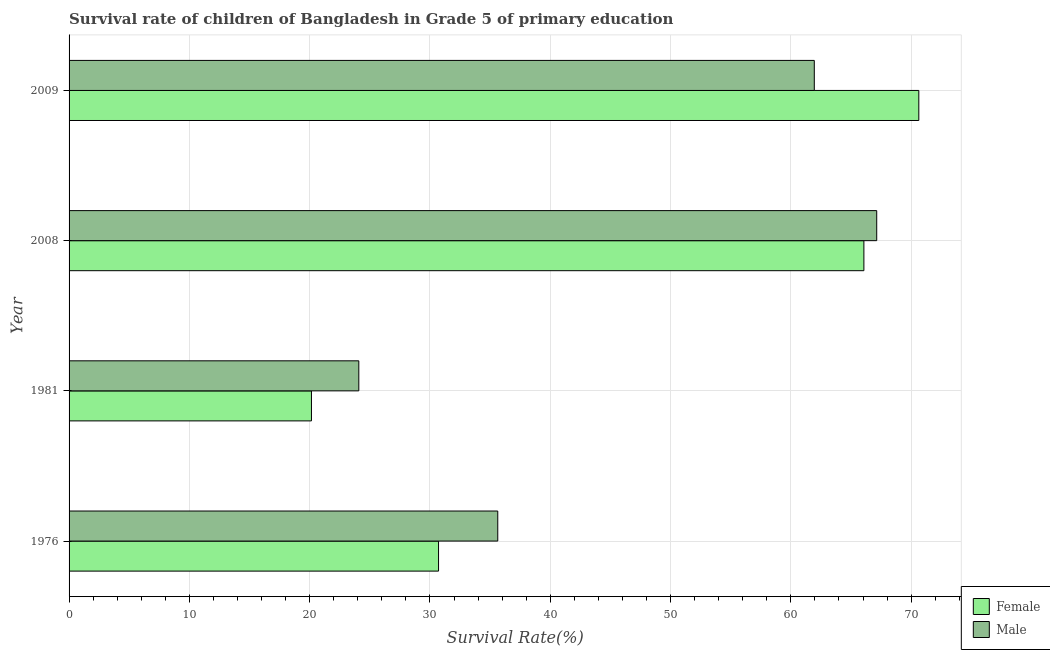How many groups of bars are there?
Give a very brief answer. 4. Are the number of bars on each tick of the Y-axis equal?
Offer a very short reply. Yes. How many bars are there on the 2nd tick from the top?
Your answer should be compact. 2. What is the label of the 1st group of bars from the top?
Your answer should be very brief. 2009. What is the survival rate of male students in primary education in 1976?
Provide a succinct answer. 35.64. Across all years, what is the maximum survival rate of female students in primary education?
Provide a succinct answer. 70.64. Across all years, what is the minimum survival rate of female students in primary education?
Provide a succinct answer. 20.15. What is the total survival rate of male students in primary education in the graph?
Ensure brevity in your answer.  188.81. What is the difference between the survival rate of female students in primary education in 2008 and that in 2009?
Give a very brief answer. -4.57. What is the difference between the survival rate of male students in primary education in 1976 and the survival rate of female students in primary education in 2008?
Your answer should be very brief. -30.43. What is the average survival rate of female students in primary education per year?
Make the answer very short. 46.89. In the year 1981, what is the difference between the survival rate of female students in primary education and survival rate of male students in primary education?
Make the answer very short. -3.94. What is the ratio of the survival rate of female students in primary education in 1976 to that in 2009?
Provide a short and direct response. 0.43. Is the survival rate of male students in primary education in 2008 less than that in 2009?
Your answer should be very brief. No. Is the difference between the survival rate of female students in primary education in 2008 and 2009 greater than the difference between the survival rate of male students in primary education in 2008 and 2009?
Make the answer very short. No. What is the difference between the highest and the second highest survival rate of male students in primary education?
Offer a very short reply. 5.19. What is the difference between the highest and the lowest survival rate of female students in primary education?
Keep it short and to the point. 50.49. In how many years, is the survival rate of male students in primary education greater than the average survival rate of male students in primary education taken over all years?
Your response must be concise. 2. What does the 2nd bar from the top in 2009 represents?
Make the answer very short. Female. How many bars are there?
Offer a terse response. 8. Are the values on the major ticks of X-axis written in scientific E-notation?
Your answer should be very brief. No. Where does the legend appear in the graph?
Offer a very short reply. Bottom right. How many legend labels are there?
Give a very brief answer. 2. How are the legend labels stacked?
Provide a short and direct response. Vertical. What is the title of the graph?
Provide a short and direct response. Survival rate of children of Bangladesh in Grade 5 of primary education. Does "Male labourers" appear as one of the legend labels in the graph?
Offer a very short reply. No. What is the label or title of the X-axis?
Offer a very short reply. Survival Rate(%). What is the label or title of the Y-axis?
Give a very brief answer. Year. What is the Survival Rate(%) of Female in 1976?
Keep it short and to the point. 30.71. What is the Survival Rate(%) of Male in 1976?
Your response must be concise. 35.64. What is the Survival Rate(%) of Female in 1981?
Make the answer very short. 20.15. What is the Survival Rate(%) of Male in 1981?
Ensure brevity in your answer.  24.09. What is the Survival Rate(%) of Female in 2008?
Keep it short and to the point. 66.07. What is the Survival Rate(%) of Male in 2008?
Provide a short and direct response. 67.14. What is the Survival Rate(%) in Female in 2009?
Provide a succinct answer. 70.64. What is the Survival Rate(%) of Male in 2009?
Provide a succinct answer. 61.95. Across all years, what is the maximum Survival Rate(%) in Female?
Ensure brevity in your answer.  70.64. Across all years, what is the maximum Survival Rate(%) in Male?
Provide a short and direct response. 67.14. Across all years, what is the minimum Survival Rate(%) of Female?
Your answer should be compact. 20.15. Across all years, what is the minimum Survival Rate(%) in Male?
Give a very brief answer. 24.09. What is the total Survival Rate(%) in Female in the graph?
Ensure brevity in your answer.  187.57. What is the total Survival Rate(%) of Male in the graph?
Ensure brevity in your answer.  188.81. What is the difference between the Survival Rate(%) of Female in 1976 and that in 1981?
Provide a succinct answer. 10.57. What is the difference between the Survival Rate(%) in Male in 1976 and that in 1981?
Your answer should be compact. 11.55. What is the difference between the Survival Rate(%) in Female in 1976 and that in 2008?
Provide a short and direct response. -35.36. What is the difference between the Survival Rate(%) in Male in 1976 and that in 2008?
Make the answer very short. -31.5. What is the difference between the Survival Rate(%) in Female in 1976 and that in 2009?
Provide a short and direct response. -39.92. What is the difference between the Survival Rate(%) in Male in 1976 and that in 2009?
Your answer should be compact. -26.31. What is the difference between the Survival Rate(%) of Female in 1981 and that in 2008?
Provide a short and direct response. -45.92. What is the difference between the Survival Rate(%) of Male in 1981 and that in 2008?
Offer a very short reply. -43.05. What is the difference between the Survival Rate(%) in Female in 1981 and that in 2009?
Your response must be concise. -50.49. What is the difference between the Survival Rate(%) of Male in 1981 and that in 2009?
Your answer should be very brief. -37.86. What is the difference between the Survival Rate(%) in Female in 2008 and that in 2009?
Keep it short and to the point. -4.57. What is the difference between the Survival Rate(%) of Male in 2008 and that in 2009?
Offer a terse response. 5.19. What is the difference between the Survival Rate(%) of Female in 1976 and the Survival Rate(%) of Male in 1981?
Provide a short and direct response. 6.63. What is the difference between the Survival Rate(%) in Female in 1976 and the Survival Rate(%) in Male in 2008?
Your answer should be very brief. -36.42. What is the difference between the Survival Rate(%) of Female in 1976 and the Survival Rate(%) of Male in 2009?
Give a very brief answer. -31.24. What is the difference between the Survival Rate(%) in Female in 1981 and the Survival Rate(%) in Male in 2008?
Provide a succinct answer. -46.99. What is the difference between the Survival Rate(%) of Female in 1981 and the Survival Rate(%) of Male in 2009?
Your answer should be compact. -41.8. What is the difference between the Survival Rate(%) in Female in 2008 and the Survival Rate(%) in Male in 2009?
Ensure brevity in your answer.  4.12. What is the average Survival Rate(%) of Female per year?
Offer a terse response. 46.89. What is the average Survival Rate(%) of Male per year?
Provide a succinct answer. 47.2. In the year 1976, what is the difference between the Survival Rate(%) of Female and Survival Rate(%) of Male?
Give a very brief answer. -4.92. In the year 1981, what is the difference between the Survival Rate(%) in Female and Survival Rate(%) in Male?
Your answer should be compact. -3.94. In the year 2008, what is the difference between the Survival Rate(%) in Female and Survival Rate(%) in Male?
Your answer should be compact. -1.07. In the year 2009, what is the difference between the Survival Rate(%) of Female and Survival Rate(%) of Male?
Offer a terse response. 8.69. What is the ratio of the Survival Rate(%) in Female in 1976 to that in 1981?
Offer a terse response. 1.52. What is the ratio of the Survival Rate(%) of Male in 1976 to that in 1981?
Make the answer very short. 1.48. What is the ratio of the Survival Rate(%) of Female in 1976 to that in 2008?
Offer a very short reply. 0.46. What is the ratio of the Survival Rate(%) of Male in 1976 to that in 2008?
Your answer should be compact. 0.53. What is the ratio of the Survival Rate(%) of Female in 1976 to that in 2009?
Ensure brevity in your answer.  0.43. What is the ratio of the Survival Rate(%) in Male in 1976 to that in 2009?
Offer a terse response. 0.58. What is the ratio of the Survival Rate(%) in Female in 1981 to that in 2008?
Offer a very short reply. 0.3. What is the ratio of the Survival Rate(%) in Male in 1981 to that in 2008?
Offer a terse response. 0.36. What is the ratio of the Survival Rate(%) in Female in 1981 to that in 2009?
Give a very brief answer. 0.29. What is the ratio of the Survival Rate(%) of Male in 1981 to that in 2009?
Provide a short and direct response. 0.39. What is the ratio of the Survival Rate(%) of Female in 2008 to that in 2009?
Make the answer very short. 0.94. What is the ratio of the Survival Rate(%) in Male in 2008 to that in 2009?
Provide a short and direct response. 1.08. What is the difference between the highest and the second highest Survival Rate(%) in Female?
Your answer should be very brief. 4.57. What is the difference between the highest and the second highest Survival Rate(%) of Male?
Your answer should be very brief. 5.19. What is the difference between the highest and the lowest Survival Rate(%) of Female?
Offer a very short reply. 50.49. What is the difference between the highest and the lowest Survival Rate(%) of Male?
Offer a very short reply. 43.05. 